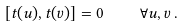<formula> <loc_0><loc_0><loc_500><loc_500>[ t ( u ) , t ( v ) ] = 0 \quad \forall u , v \, .</formula> 